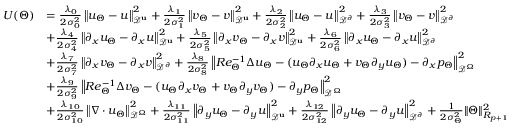<formula> <loc_0><loc_0><loc_500><loc_500>\begin{array} { r l } { U ( \Theta ) } & { = \frac { \lambda _ { 0 } } { 2 \sigma _ { 0 } ^ { 2 } } \left \| u _ { \Theta } - u \right \| _ { \mathcal { D } ^ { u } } ^ { 2 } + \frac { \lambda _ { 1 } } { 2 \sigma _ { 1 } ^ { 2 } } \left \| v _ { \Theta } - v \right \| _ { \mathcal { D } ^ { u } } ^ { 2 } + \frac { \lambda _ { 2 } } { 2 \sigma _ { 2 } ^ { 2 } } \left \| u _ { \Theta } - u \right \| _ { \mathcal { D } ^ { \partial } } ^ { 2 } + \frac { \lambda _ { 3 } } { 2 \sigma _ { 3 } ^ { 2 } } \left \| v _ { \Theta } - v \right \| _ { \mathcal { D } ^ { \partial } } ^ { 2 } } \\ & { + \frac { \lambda _ { 4 } } { 2 \sigma _ { 4 } ^ { 2 } } \left \| \partial _ { x } u _ { \Theta } - \partial _ { x } u \right \| _ { \mathcal { D } ^ { u } } ^ { 2 } + \frac { \lambda _ { 5 } } { 2 \sigma _ { 5 } ^ { 2 } } \left \| \partial _ { x } v _ { \Theta } - \partial _ { x } v \right \| _ { \mathcal { D } ^ { u } } ^ { 2 } + \frac { \lambda _ { 6 } } { 2 \sigma _ { 6 } ^ { 2 } } \left \| \partial _ { x } u _ { \Theta } - \partial _ { x } u \right \| _ { \mathcal { D } ^ { \partial } } ^ { 2 } } \\ & { + \frac { \lambda _ { 7 } } { 2 \sigma _ { 7 } ^ { 2 } } \left \| \partial _ { x } v _ { \Theta } - \partial _ { x } v \right \| _ { \mathcal { D } ^ { \partial } } ^ { 2 } + \frac { \lambda _ { 8 } } { 2 \sigma _ { 8 } ^ { 2 } } \left \| R e _ { \Theta } ^ { - 1 } \Delta u _ { \Theta } - ( u _ { \Theta } \partial _ { x } u _ { \Theta } + v _ { \Theta } \partial _ { y } u _ { \Theta } ) - \partial _ { x } p _ { \Theta } \right \| _ { \mathcal { D } ^ { \Omega } } ^ { 2 } } \\ & { + \frac { \lambda _ { 9 } } { 2 \sigma _ { 9 } ^ { 2 } } \left \| R e _ { \Theta } ^ { - 1 } \Delta v _ { \Theta } - ( u _ { \Theta } \partial _ { x } v _ { \Theta } + v _ { \Theta } \partial _ { y } v _ { \Theta } ) - \partial _ { y } p _ { \Theta } \right \| _ { \mathcal { D } ^ { \Omega } } ^ { 2 } } \\ & { + \frac { \lambda _ { 1 0 } } { 2 \sigma _ { 1 0 } ^ { 2 } } \left \| \nabla \cdot u _ { \Theta } \right \| _ { \mathcal { D } ^ { \Omega } } ^ { 2 } + \frac { \lambda _ { 1 1 } } { 2 \sigma _ { 1 1 } ^ { 2 } } \left \| \partial _ { y } u _ { \Theta } - \partial _ { y } u \right \| _ { \mathcal { D } ^ { u } } ^ { 2 } + \frac { \lambda _ { 1 2 } } { 2 \sigma _ { 1 2 } ^ { 2 } } \left \| \partial _ { y } u _ { \Theta } - \partial _ { y } u \right \| _ { \mathcal { D } ^ { \partial } } ^ { 2 } + \frac { 1 } { 2 \sigma _ { \Theta } ^ { 2 } } \| \Theta \| _ { R _ { p + 1 } } ^ { 2 } } \end{array}</formula> 